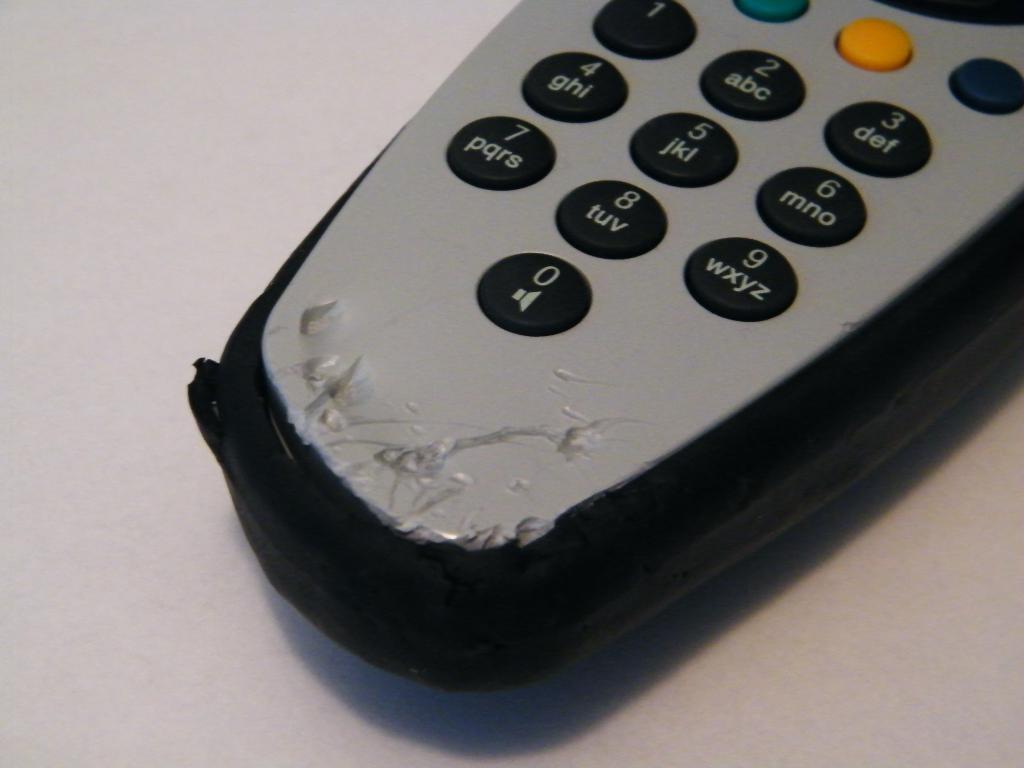What number does the button on the bottom say?
Offer a terse response. 0. 